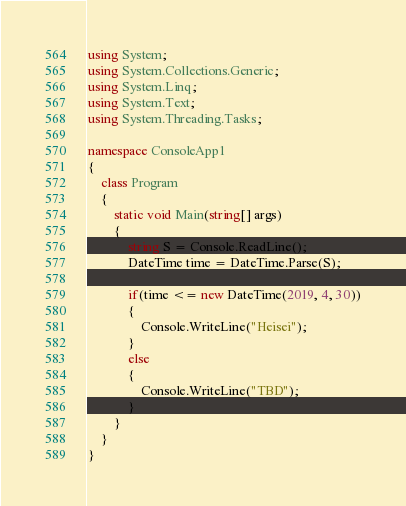Convert code to text. <code><loc_0><loc_0><loc_500><loc_500><_C#_>using System;
using System.Collections.Generic;
using System.Linq;
using System.Text;
using System.Threading.Tasks;

namespace ConsoleApp1
{
    class Program
    {
        static void Main(string[] args)
        {
            string S = Console.ReadLine();
            DateTime time = DateTime.Parse(S);

            if(time <= new DateTime(2019, 4, 30))
            {
                Console.WriteLine("Heisei");
            }
            else
            {
                Console.WriteLine("TBD");
            }
        }
    }
}
</code> 